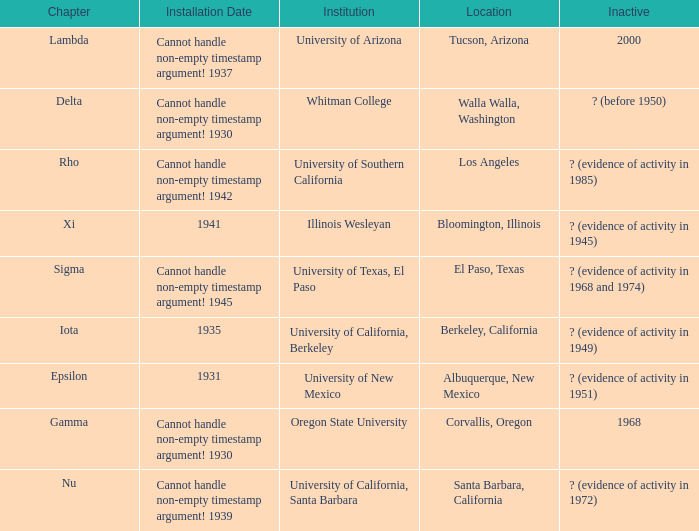When was the installation day in el paso, texas? Cannot handle non-empty timestamp argument! 1945. 